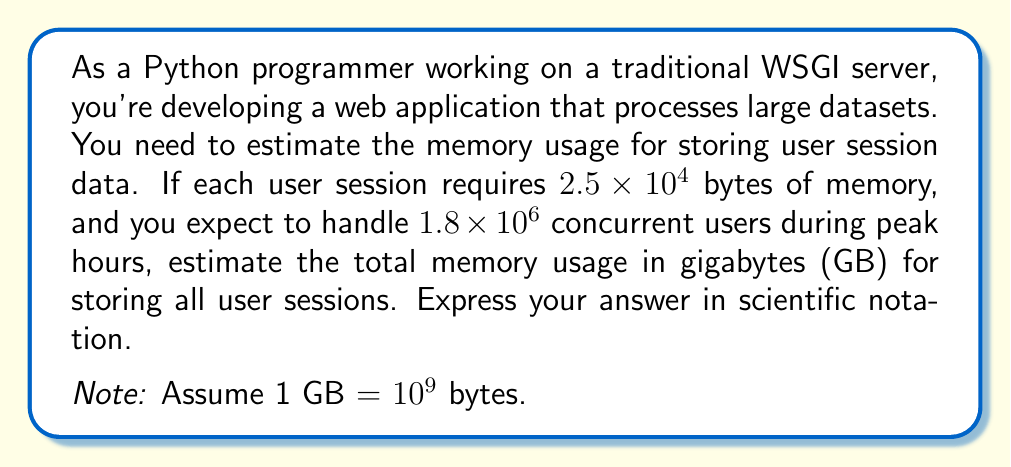Can you solve this math problem? To solve this problem, we'll follow these steps:

1. Calculate the total memory usage in bytes:
   $$\text{Total bytes} = \text{Bytes per session} \times \text{Number of concurrent users}$$
   $$\text{Total bytes} = (2.5 \times 10^4) \times (1.8 \times 10^6)$$

2. Multiply the exponents:
   $$\text{Total bytes} = 2.5 \times 1.8 \times 10^{4+6}$$
   $$\text{Total bytes} = 4.5 \times 10^{10} \text{ bytes}$$

3. Convert bytes to gigabytes:
   $$\text{GB} = \frac{\text{Total bytes}}{10^9 \text{ bytes/GB}}$$
   $$\text{GB} = \frac{4.5 \times 10^{10}}{10^9}$$

4. Simplify the division:
   $$\text{GB} = 4.5 \times 10^{10-9}$$
   $$\text{GB} = 4.5 \times 10^1$$

Therefore, the estimated memory usage is $4.5 \times 10^1$ GB.
Answer: $4.5 \times 10^1$ GB 